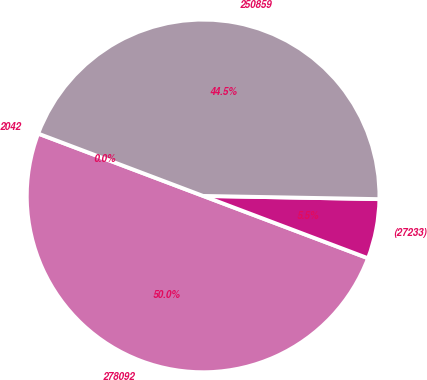Convert chart. <chart><loc_0><loc_0><loc_500><loc_500><pie_chart><fcel>2042<fcel>278092<fcel>(27233)<fcel>250859<nl><fcel>0.0%<fcel>50.0%<fcel>5.46%<fcel>44.54%<nl></chart> 